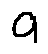<formula> <loc_0><loc_0><loc_500><loc_500>a</formula> 